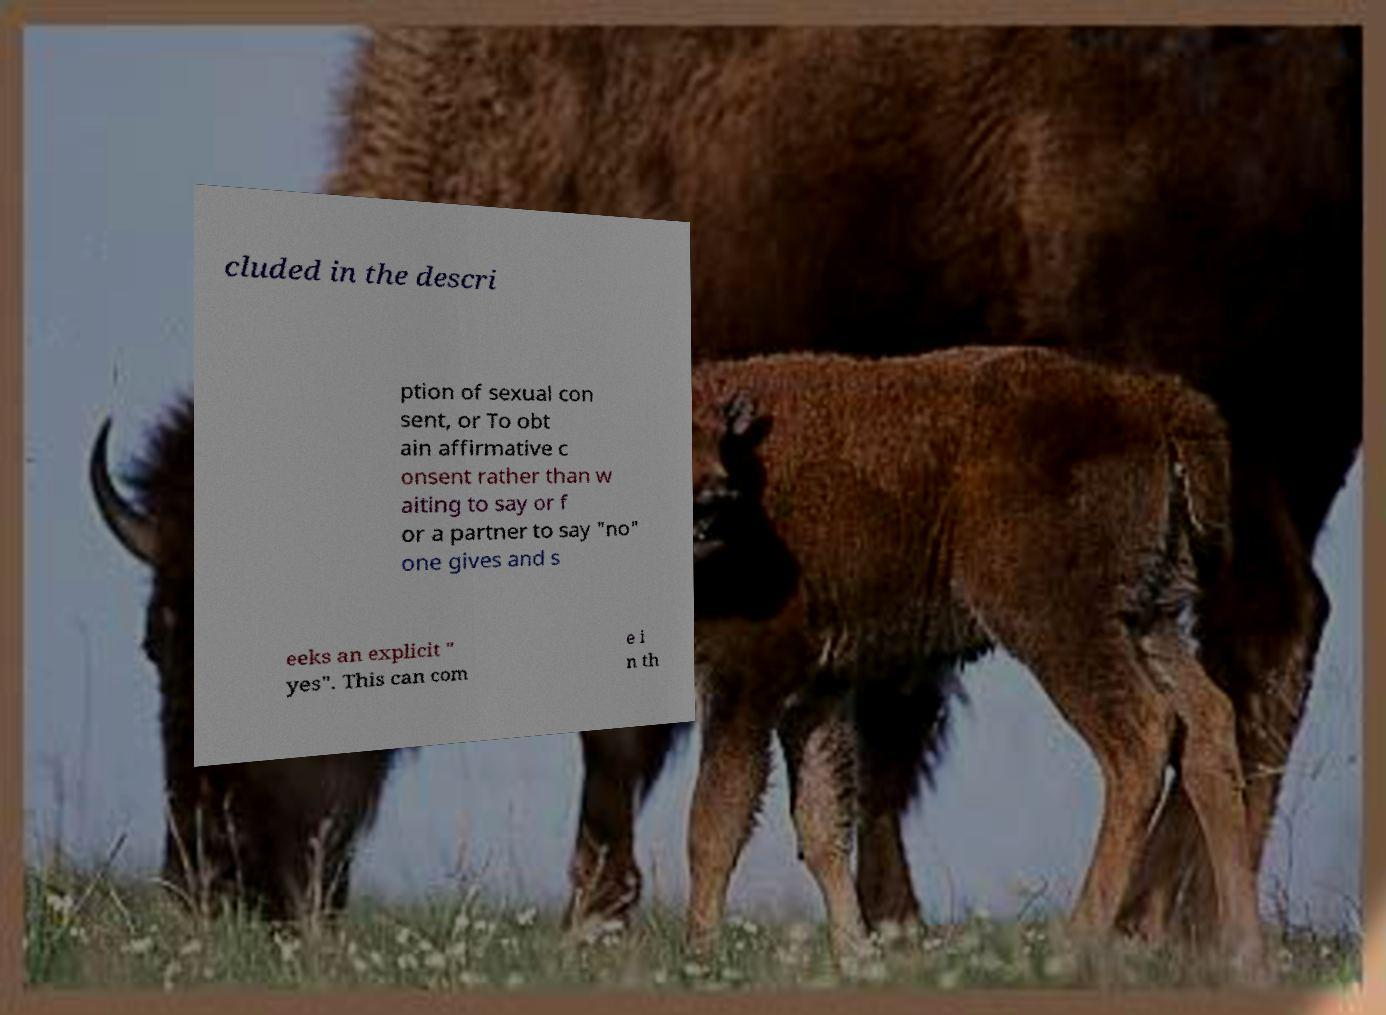Could you assist in decoding the text presented in this image and type it out clearly? cluded in the descri ption of sexual con sent, or To obt ain affirmative c onsent rather than w aiting to say or f or a partner to say "no" one gives and s eeks an explicit " yes". This can com e i n th 